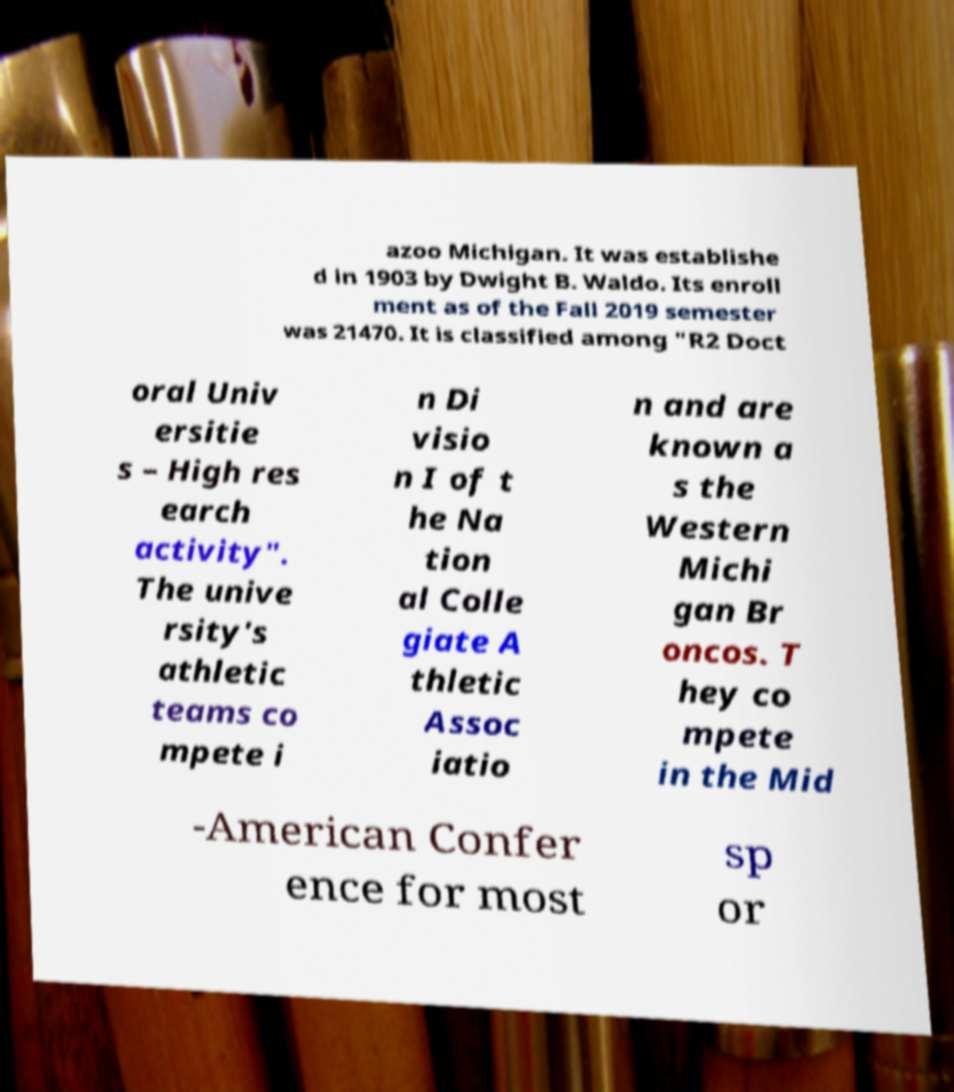There's text embedded in this image that I need extracted. Can you transcribe it verbatim? azoo Michigan. It was establishe d in 1903 by Dwight B. Waldo. Its enroll ment as of the Fall 2019 semester was 21470. It is classified among "R2 Doct oral Univ ersitie s – High res earch activity". The unive rsity's athletic teams co mpete i n Di visio n I of t he Na tion al Colle giate A thletic Assoc iatio n and are known a s the Western Michi gan Br oncos. T hey co mpete in the Mid -American Confer ence for most sp or 